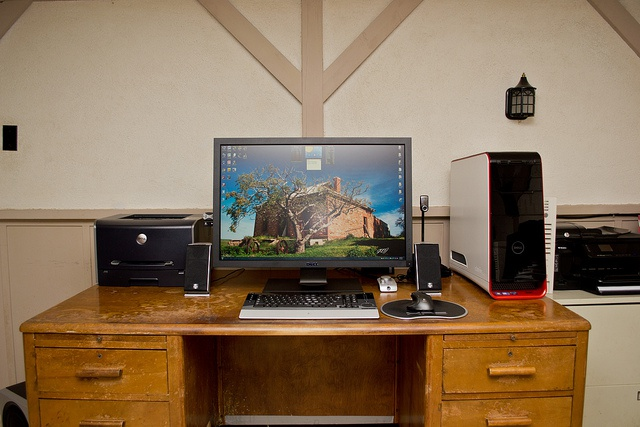Describe the objects in this image and their specific colors. I can see tv in black, darkgray, and gray tones, keyboard in black, lightgray, and gray tones, mouse in black, gray, and darkgray tones, and remote in black, lightgray, darkgray, and gray tones in this image. 